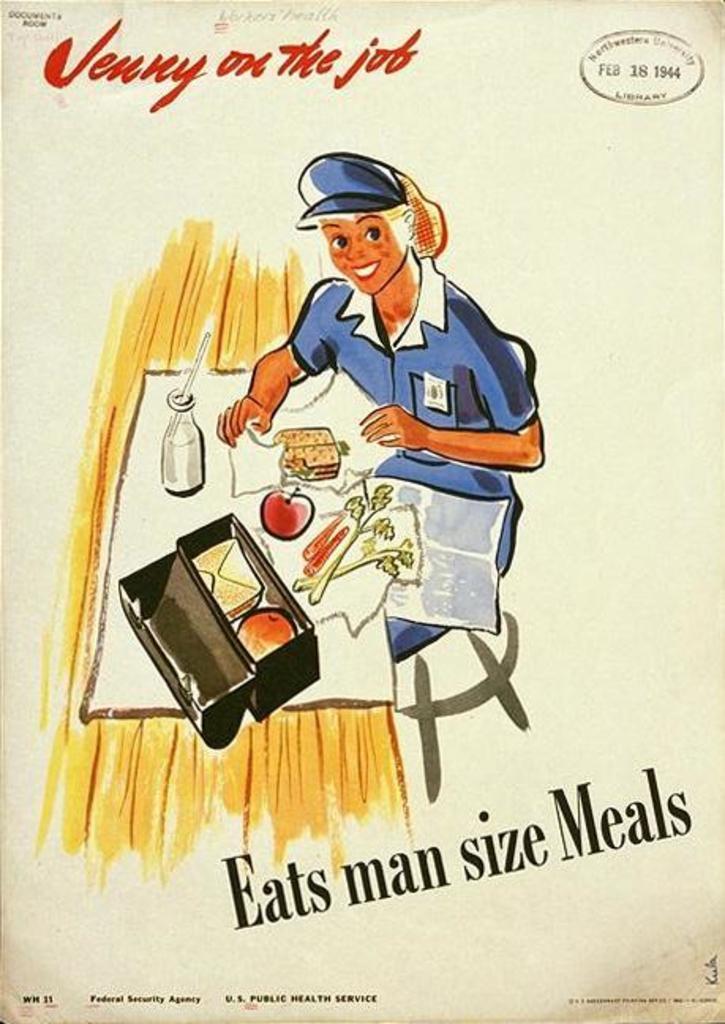What size meals should you eat?
Provide a short and direct response. Man size. What does the text in red say?
Your answer should be compact. Jenny on the job. 